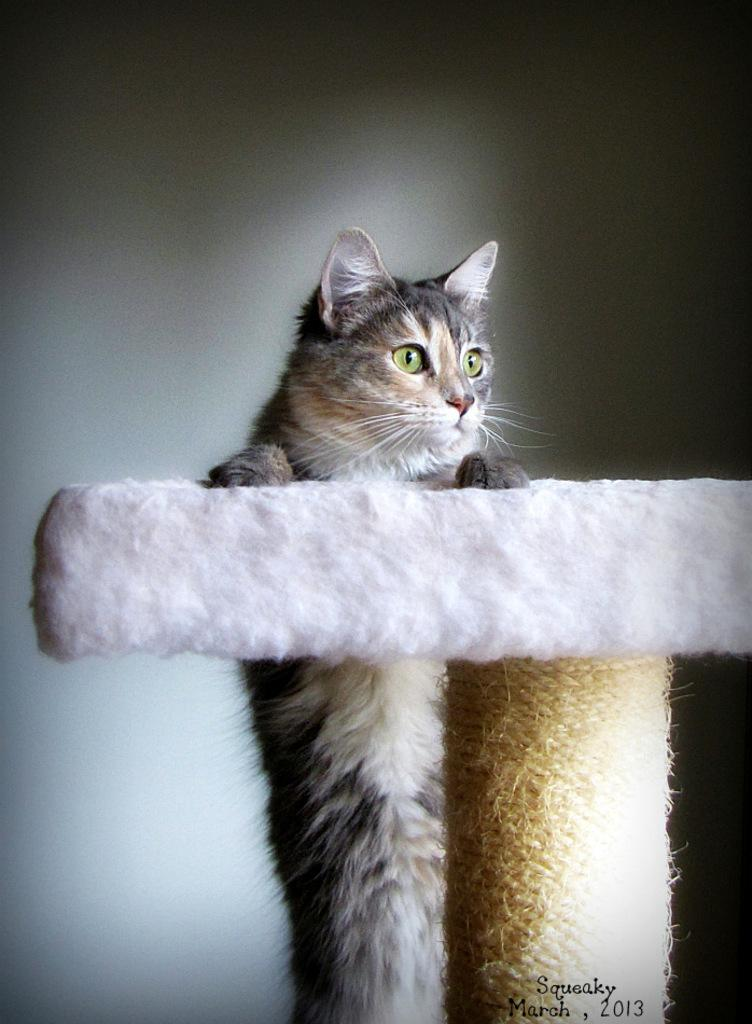What is the main subject of the image? There is a cat in the center of the image. What is the cat doing in the image? The cat is holding an object. What can be seen behind the cat? There is a wall behind the cat. What example of a tub can be seen in the image? There is no tub present in the image. How does the cat say good-bye to the object it is holding in the image? The image does not depict the cat saying good-bye to the object it is holding. 